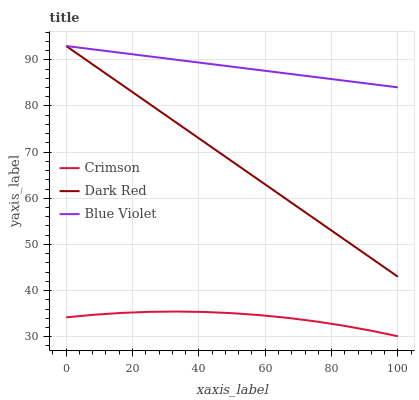Does Dark Red have the minimum area under the curve?
Answer yes or no. No. Does Dark Red have the maximum area under the curve?
Answer yes or no. No. Is Dark Red the smoothest?
Answer yes or no. No. Is Dark Red the roughest?
Answer yes or no. No. Does Dark Red have the lowest value?
Answer yes or no. No. Is Crimson less than Dark Red?
Answer yes or no. Yes. Is Blue Violet greater than Crimson?
Answer yes or no. Yes. Does Crimson intersect Dark Red?
Answer yes or no. No. 